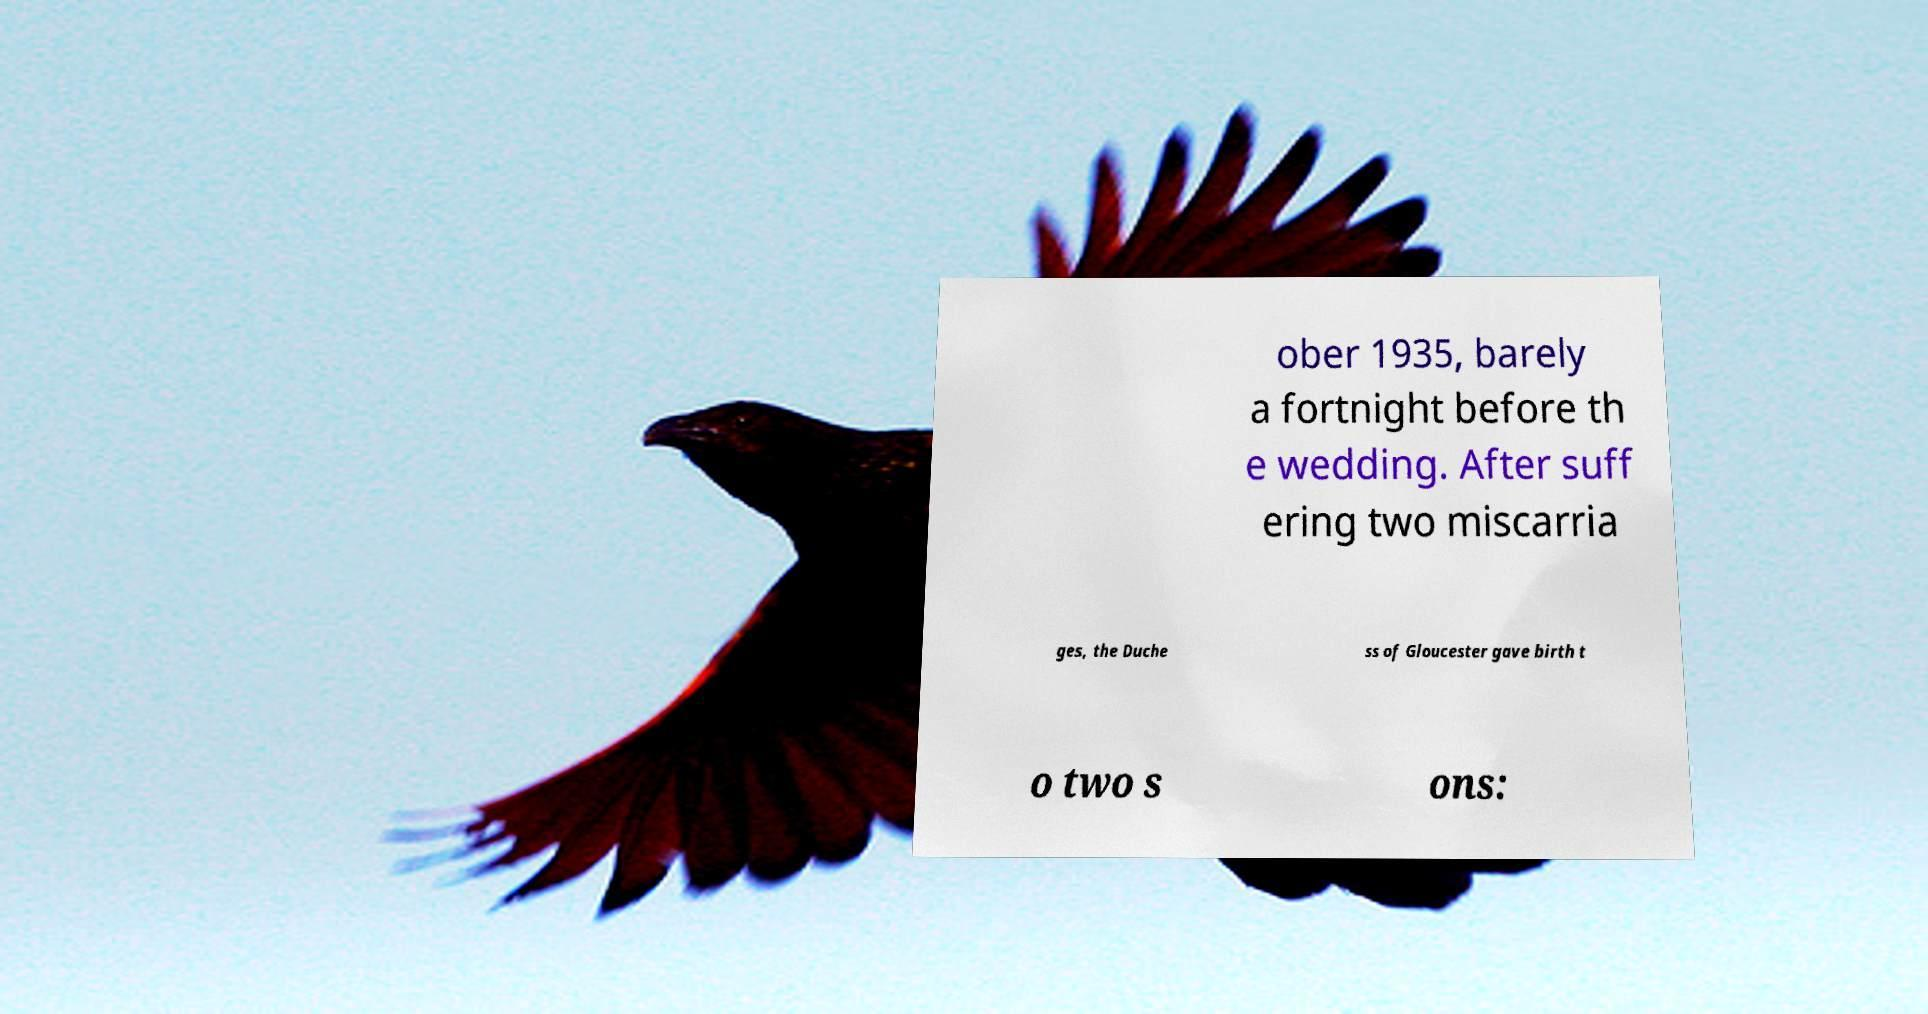Can you read and provide the text displayed in the image?This photo seems to have some interesting text. Can you extract and type it out for me? ober 1935, barely a fortnight before th e wedding. After suff ering two miscarria ges, the Duche ss of Gloucester gave birth t o two s ons: 